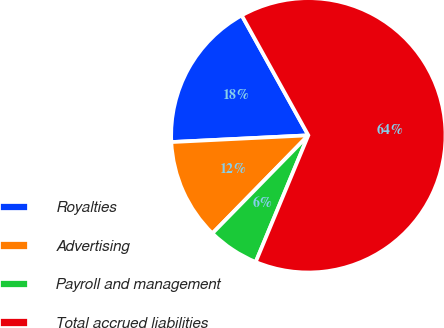Convert chart. <chart><loc_0><loc_0><loc_500><loc_500><pie_chart><fcel>Royalties<fcel>Advertising<fcel>Payroll and management<fcel>Total accrued liabilities<nl><fcel>17.72%<fcel>11.89%<fcel>6.06%<fcel>64.34%<nl></chart> 